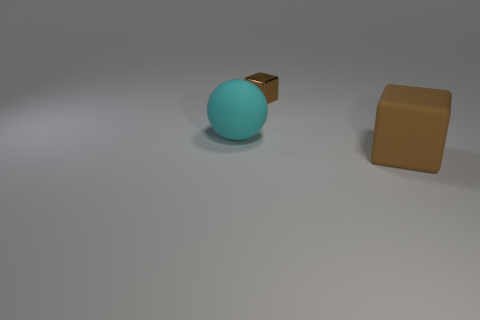Add 2 cyan shiny objects. How many objects exist? 5 Subtract all balls. How many objects are left? 2 Subtract 0 purple cylinders. How many objects are left? 3 Subtract all brown matte objects. Subtract all rubber objects. How many objects are left? 0 Add 1 brown matte blocks. How many brown matte blocks are left? 2 Add 3 large cyan things. How many large cyan things exist? 4 